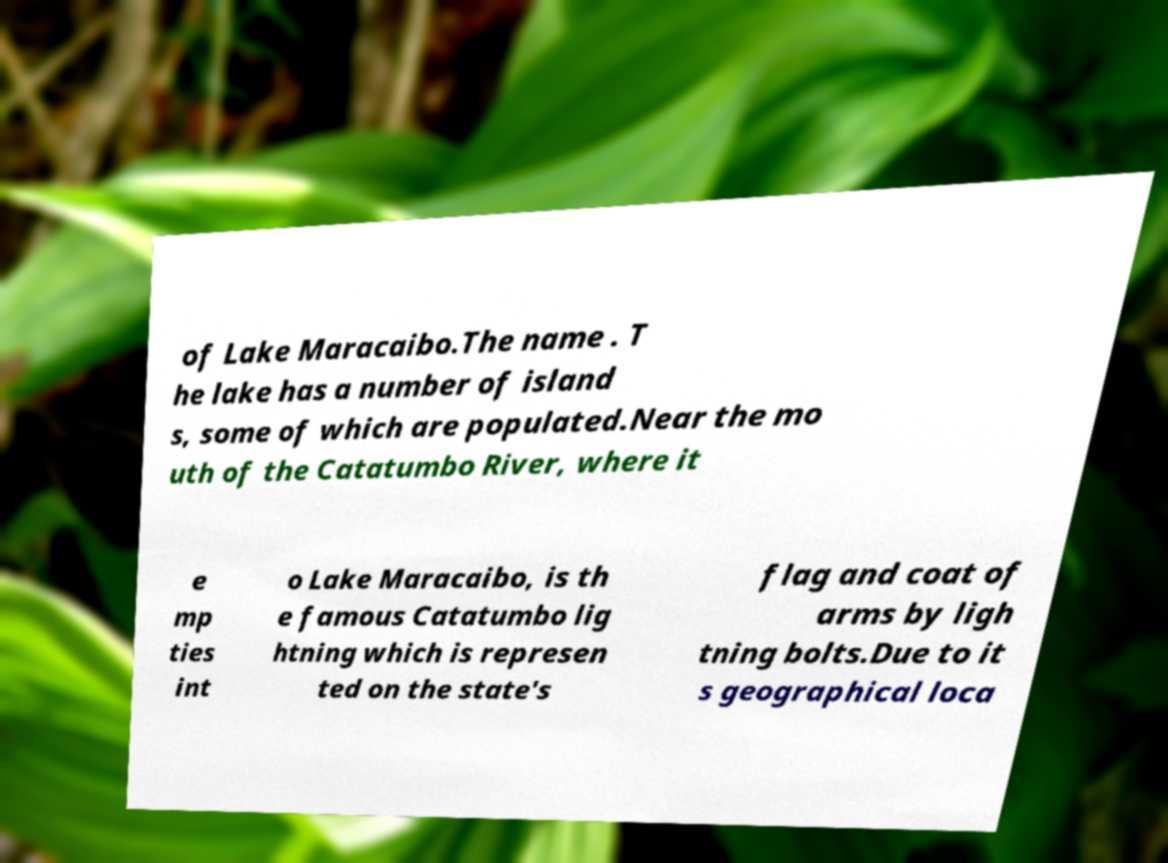Could you extract and type out the text from this image? of Lake Maracaibo.The name . T he lake has a number of island s, some of which are populated.Near the mo uth of the Catatumbo River, where it e mp ties int o Lake Maracaibo, is th e famous Catatumbo lig htning which is represen ted on the state's flag and coat of arms by ligh tning bolts.Due to it s geographical loca 